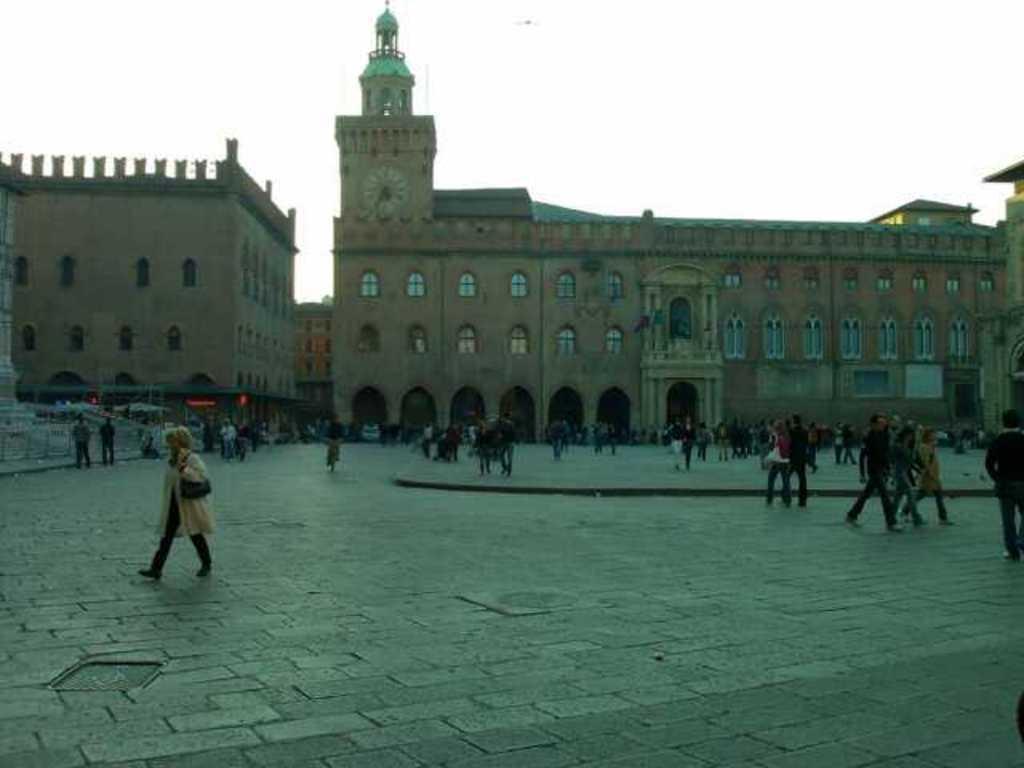Can you describe this image briefly? In this image there is a building in the middle. In front of the building there are so many people who are walking on the floor. At the top there is the sky. There is a wall clock to the building and there are so many windows in the building. 